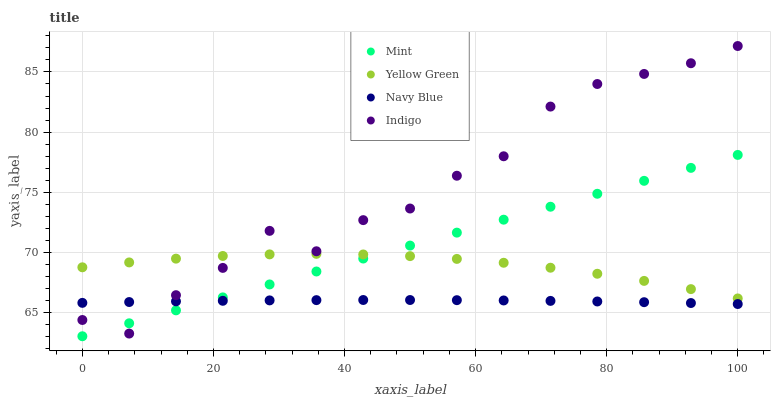Does Navy Blue have the minimum area under the curve?
Answer yes or no. Yes. Does Indigo have the maximum area under the curve?
Answer yes or no. Yes. Does Mint have the minimum area under the curve?
Answer yes or no. No. Does Mint have the maximum area under the curve?
Answer yes or no. No. Is Mint the smoothest?
Answer yes or no. Yes. Is Indigo the roughest?
Answer yes or no. Yes. Is Yellow Green the smoothest?
Answer yes or no. No. Is Yellow Green the roughest?
Answer yes or no. No. Does Mint have the lowest value?
Answer yes or no. Yes. Does Yellow Green have the lowest value?
Answer yes or no. No. Does Indigo have the highest value?
Answer yes or no. Yes. Does Mint have the highest value?
Answer yes or no. No. Is Navy Blue less than Yellow Green?
Answer yes or no. Yes. Is Yellow Green greater than Navy Blue?
Answer yes or no. Yes. Does Yellow Green intersect Mint?
Answer yes or no. Yes. Is Yellow Green less than Mint?
Answer yes or no. No. Is Yellow Green greater than Mint?
Answer yes or no. No. Does Navy Blue intersect Yellow Green?
Answer yes or no. No. 